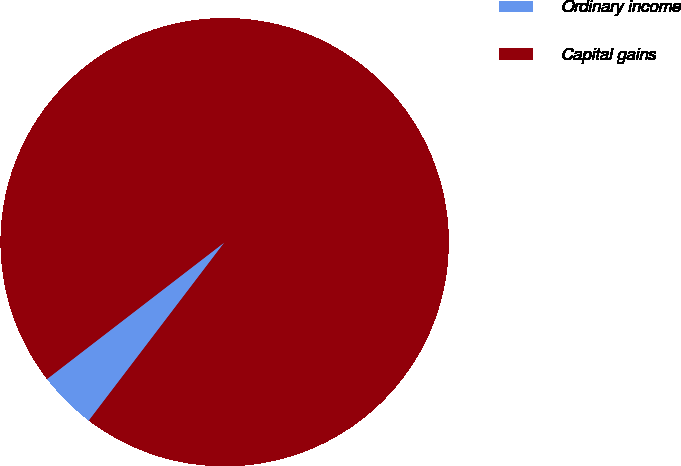<chart> <loc_0><loc_0><loc_500><loc_500><pie_chart><fcel>Ordinary income<fcel>Capital gains<nl><fcel>4.2%<fcel>95.8%<nl></chart> 